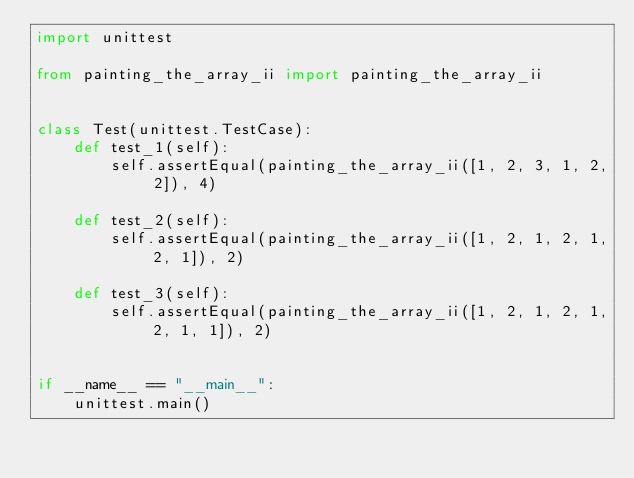Convert code to text. <code><loc_0><loc_0><loc_500><loc_500><_Python_>import unittest

from painting_the_array_ii import painting_the_array_ii


class Test(unittest.TestCase):
    def test_1(self):
        self.assertEqual(painting_the_array_ii([1, 2, 3, 1, 2, 2]), 4)

    def test_2(self):
        self.assertEqual(painting_the_array_ii([1, 2, 1, 2, 1, 2, 1]), 2)

    def test_3(self):
        self.assertEqual(painting_the_array_ii([1, 2, 1, 2, 1, 2, 1, 1]), 2)


if __name__ == "__main__":
    unittest.main()
</code> 